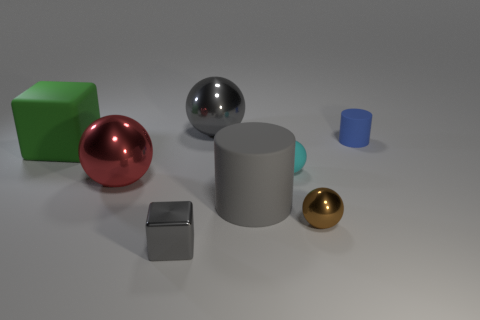Subtract all small brown spheres. How many spheres are left? 3 Subtract 2 balls. How many balls are left? 2 Subtract all red balls. How many balls are left? 3 Add 1 tiny red matte balls. How many objects exist? 9 Subtract all yellow spheres. Subtract all gray blocks. How many spheres are left? 4 Subtract all cylinders. How many objects are left? 6 Subtract all tiny cyan metallic balls. Subtract all brown metallic spheres. How many objects are left? 7 Add 1 brown objects. How many brown objects are left? 2 Add 5 cyan matte spheres. How many cyan matte spheres exist? 6 Subtract 0 purple cubes. How many objects are left? 8 